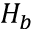<formula> <loc_0><loc_0><loc_500><loc_500>H _ { b }</formula> 